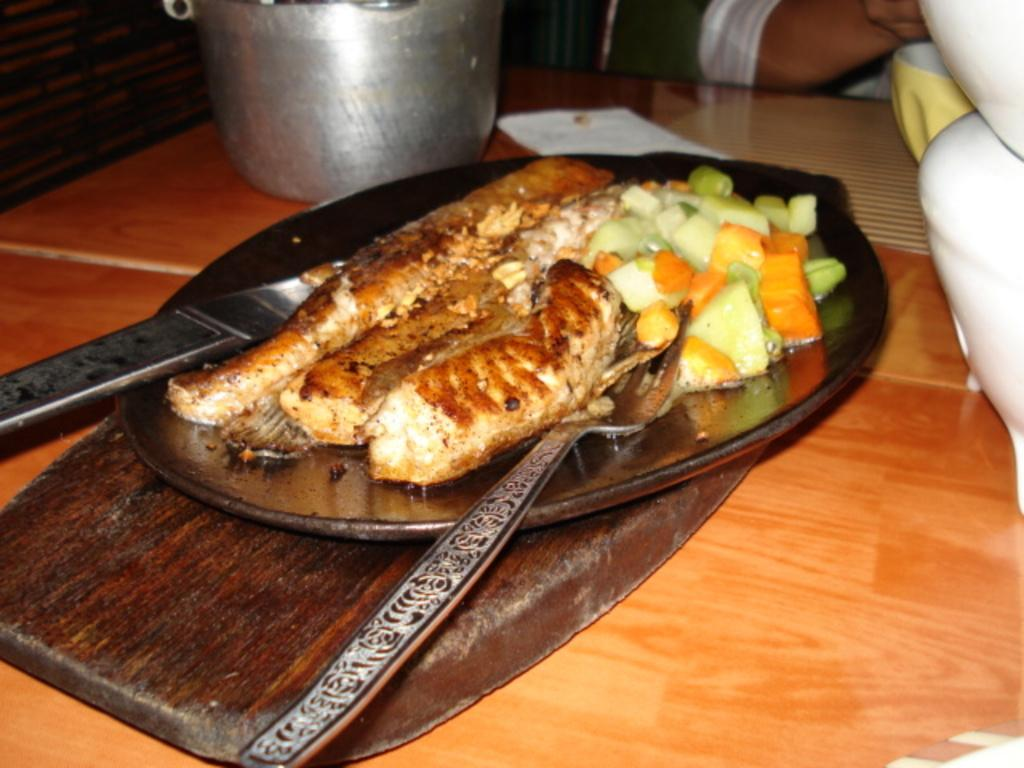What is on the plate that is visible in the image? There is a plate with food in the image. Where is the plate located in the image? The plate is placed on a table in the image. Can you describe the person in the image? The image only shows a person, but no specific details about their appearance or actions are provided. What type of destruction is the person causing in the image? There is no destruction or any indication of destructive behavior in the image. 